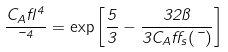<formula> <loc_0><loc_0><loc_500><loc_500>\frac { C _ { A } \gamma ^ { 4 } } { \mu ^ { 4 } } = \exp \left [ \frac { 5 } { 3 } - \frac { 3 2 \pi } { 3 C _ { A } \alpha _ { s } ( \mu ) } \right ]</formula> 